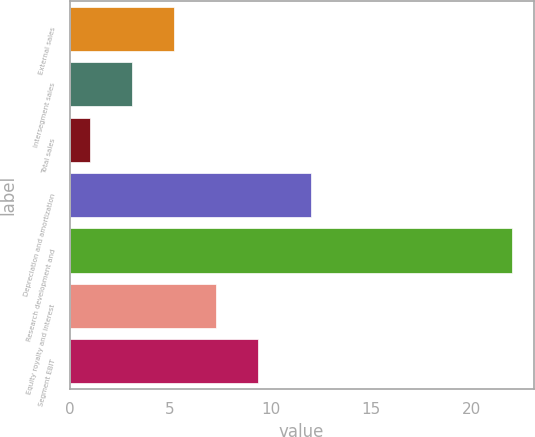Convert chart to OTSL. <chart><loc_0><loc_0><loc_500><loc_500><bar_chart><fcel>External sales<fcel>Intersegment sales<fcel>Total sales<fcel>Depreciation and amortization<fcel>Research development and<fcel>Equity royalty and interest<fcel>Segment EBIT<nl><fcel>5.2<fcel>3.1<fcel>1<fcel>12<fcel>22<fcel>7.3<fcel>9.4<nl></chart> 